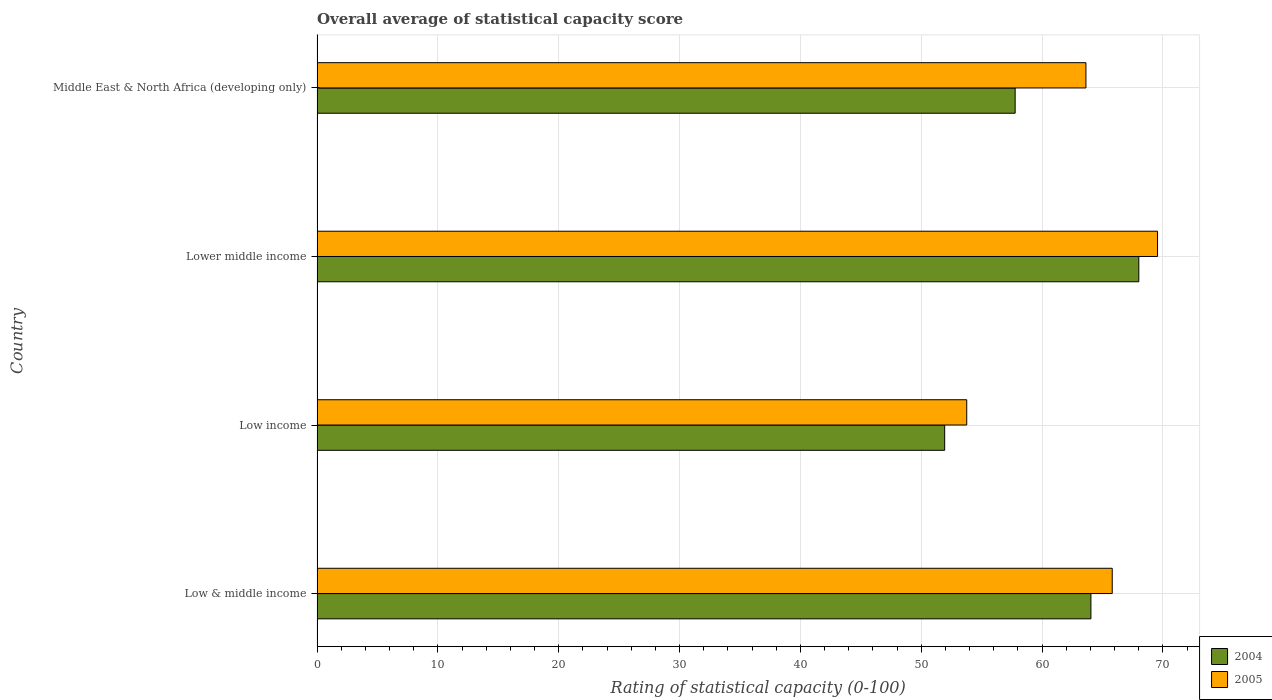How many different coloured bars are there?
Give a very brief answer. 2. Are the number of bars on each tick of the Y-axis equal?
Your answer should be very brief. Yes. How many bars are there on the 4th tick from the bottom?
Your answer should be compact. 2. What is the label of the 1st group of bars from the top?
Make the answer very short. Middle East & North Africa (developing only). In how many cases, is the number of bars for a given country not equal to the number of legend labels?
Your answer should be very brief. 0. What is the rating of statistical capacity in 2005 in Low & middle income?
Offer a terse response. 65.81. Across all countries, what is the maximum rating of statistical capacity in 2004?
Provide a short and direct response. 68.01. Across all countries, what is the minimum rating of statistical capacity in 2004?
Offer a terse response. 51.94. In which country was the rating of statistical capacity in 2005 maximum?
Give a very brief answer. Lower middle income. What is the total rating of statistical capacity in 2005 in the graph?
Your answer should be very brief. 252.78. What is the difference between the rating of statistical capacity in 2005 in Low income and that in Lower middle income?
Give a very brief answer. -15.79. What is the difference between the rating of statistical capacity in 2004 in Low income and the rating of statistical capacity in 2005 in Low & middle income?
Your answer should be very brief. -13.87. What is the average rating of statistical capacity in 2005 per country?
Give a very brief answer. 63.19. What is the difference between the rating of statistical capacity in 2005 and rating of statistical capacity in 2004 in Middle East & North Africa (developing only)?
Your answer should be compact. 5.86. What is the ratio of the rating of statistical capacity in 2004 in Lower middle income to that in Middle East & North Africa (developing only)?
Offer a terse response. 1.18. Is the difference between the rating of statistical capacity in 2005 in Low & middle income and Low income greater than the difference between the rating of statistical capacity in 2004 in Low & middle income and Low income?
Offer a terse response. No. What is the difference between the highest and the second highest rating of statistical capacity in 2004?
Give a very brief answer. 3.96. What is the difference between the highest and the lowest rating of statistical capacity in 2005?
Make the answer very short. 15.79. In how many countries, is the rating of statistical capacity in 2005 greater than the average rating of statistical capacity in 2005 taken over all countries?
Make the answer very short. 3. What does the 2nd bar from the top in Middle East & North Africa (developing only) represents?
Keep it short and to the point. 2004. Are the values on the major ticks of X-axis written in scientific E-notation?
Keep it short and to the point. No. Does the graph contain any zero values?
Your response must be concise. No. What is the title of the graph?
Offer a very short reply. Overall average of statistical capacity score. What is the label or title of the X-axis?
Your answer should be compact. Rating of statistical capacity (0-100). What is the Rating of statistical capacity (0-100) of 2004 in Low & middle income?
Keep it short and to the point. 64.05. What is the Rating of statistical capacity (0-100) in 2005 in Low & middle income?
Your answer should be compact. 65.81. What is the Rating of statistical capacity (0-100) in 2004 in Low income?
Keep it short and to the point. 51.94. What is the Rating of statistical capacity (0-100) of 2005 in Low income?
Your answer should be compact. 53.77. What is the Rating of statistical capacity (0-100) in 2004 in Lower middle income?
Your answer should be very brief. 68.01. What is the Rating of statistical capacity (0-100) in 2005 in Lower middle income?
Your answer should be compact. 69.56. What is the Rating of statistical capacity (0-100) in 2004 in Middle East & North Africa (developing only)?
Provide a short and direct response. 57.78. What is the Rating of statistical capacity (0-100) of 2005 in Middle East & North Africa (developing only)?
Offer a very short reply. 63.64. Across all countries, what is the maximum Rating of statistical capacity (0-100) in 2004?
Make the answer very short. 68.01. Across all countries, what is the maximum Rating of statistical capacity (0-100) in 2005?
Your answer should be very brief. 69.56. Across all countries, what is the minimum Rating of statistical capacity (0-100) in 2004?
Offer a terse response. 51.94. Across all countries, what is the minimum Rating of statistical capacity (0-100) in 2005?
Offer a terse response. 53.77. What is the total Rating of statistical capacity (0-100) of 2004 in the graph?
Offer a terse response. 241.78. What is the total Rating of statistical capacity (0-100) of 2005 in the graph?
Your answer should be compact. 252.78. What is the difference between the Rating of statistical capacity (0-100) in 2004 in Low & middle income and that in Low income?
Keep it short and to the point. 12.1. What is the difference between the Rating of statistical capacity (0-100) of 2005 in Low & middle income and that in Low income?
Provide a succinct answer. 12.04. What is the difference between the Rating of statistical capacity (0-100) in 2004 in Low & middle income and that in Lower middle income?
Give a very brief answer. -3.96. What is the difference between the Rating of statistical capacity (0-100) in 2005 in Low & middle income and that in Lower middle income?
Your response must be concise. -3.75. What is the difference between the Rating of statistical capacity (0-100) in 2004 in Low & middle income and that in Middle East & North Africa (developing only)?
Ensure brevity in your answer.  6.27. What is the difference between the Rating of statistical capacity (0-100) of 2005 in Low & middle income and that in Middle East & North Africa (developing only)?
Your response must be concise. 2.18. What is the difference between the Rating of statistical capacity (0-100) of 2004 in Low income and that in Lower middle income?
Keep it short and to the point. -16.07. What is the difference between the Rating of statistical capacity (0-100) of 2005 in Low income and that in Lower middle income?
Your answer should be very brief. -15.79. What is the difference between the Rating of statistical capacity (0-100) in 2004 in Low income and that in Middle East & North Africa (developing only)?
Your response must be concise. -5.83. What is the difference between the Rating of statistical capacity (0-100) in 2005 in Low income and that in Middle East & North Africa (developing only)?
Keep it short and to the point. -9.87. What is the difference between the Rating of statistical capacity (0-100) of 2004 in Lower middle income and that in Middle East & North Africa (developing only)?
Give a very brief answer. 10.23. What is the difference between the Rating of statistical capacity (0-100) of 2005 in Lower middle income and that in Middle East & North Africa (developing only)?
Make the answer very short. 5.92. What is the difference between the Rating of statistical capacity (0-100) of 2004 in Low & middle income and the Rating of statistical capacity (0-100) of 2005 in Low income?
Your response must be concise. 10.28. What is the difference between the Rating of statistical capacity (0-100) in 2004 in Low & middle income and the Rating of statistical capacity (0-100) in 2005 in Lower middle income?
Your answer should be very brief. -5.51. What is the difference between the Rating of statistical capacity (0-100) of 2004 in Low & middle income and the Rating of statistical capacity (0-100) of 2005 in Middle East & North Africa (developing only)?
Your answer should be very brief. 0.41. What is the difference between the Rating of statistical capacity (0-100) in 2004 in Low income and the Rating of statistical capacity (0-100) in 2005 in Lower middle income?
Your answer should be compact. -17.62. What is the difference between the Rating of statistical capacity (0-100) of 2004 in Low income and the Rating of statistical capacity (0-100) of 2005 in Middle East & North Africa (developing only)?
Give a very brief answer. -11.69. What is the difference between the Rating of statistical capacity (0-100) of 2004 in Lower middle income and the Rating of statistical capacity (0-100) of 2005 in Middle East & North Africa (developing only)?
Your answer should be very brief. 4.38. What is the average Rating of statistical capacity (0-100) in 2004 per country?
Keep it short and to the point. 60.45. What is the average Rating of statistical capacity (0-100) in 2005 per country?
Ensure brevity in your answer.  63.19. What is the difference between the Rating of statistical capacity (0-100) in 2004 and Rating of statistical capacity (0-100) in 2005 in Low & middle income?
Ensure brevity in your answer.  -1.76. What is the difference between the Rating of statistical capacity (0-100) of 2004 and Rating of statistical capacity (0-100) of 2005 in Low income?
Give a very brief answer. -1.83. What is the difference between the Rating of statistical capacity (0-100) in 2004 and Rating of statistical capacity (0-100) in 2005 in Lower middle income?
Your answer should be compact. -1.55. What is the difference between the Rating of statistical capacity (0-100) in 2004 and Rating of statistical capacity (0-100) in 2005 in Middle East & North Africa (developing only)?
Offer a terse response. -5.86. What is the ratio of the Rating of statistical capacity (0-100) of 2004 in Low & middle income to that in Low income?
Ensure brevity in your answer.  1.23. What is the ratio of the Rating of statistical capacity (0-100) in 2005 in Low & middle income to that in Low income?
Make the answer very short. 1.22. What is the ratio of the Rating of statistical capacity (0-100) of 2004 in Low & middle income to that in Lower middle income?
Offer a very short reply. 0.94. What is the ratio of the Rating of statistical capacity (0-100) of 2005 in Low & middle income to that in Lower middle income?
Your response must be concise. 0.95. What is the ratio of the Rating of statistical capacity (0-100) of 2004 in Low & middle income to that in Middle East & North Africa (developing only)?
Your answer should be compact. 1.11. What is the ratio of the Rating of statistical capacity (0-100) of 2005 in Low & middle income to that in Middle East & North Africa (developing only)?
Provide a short and direct response. 1.03. What is the ratio of the Rating of statistical capacity (0-100) of 2004 in Low income to that in Lower middle income?
Keep it short and to the point. 0.76. What is the ratio of the Rating of statistical capacity (0-100) in 2005 in Low income to that in Lower middle income?
Ensure brevity in your answer.  0.77. What is the ratio of the Rating of statistical capacity (0-100) in 2004 in Low income to that in Middle East & North Africa (developing only)?
Offer a terse response. 0.9. What is the ratio of the Rating of statistical capacity (0-100) in 2005 in Low income to that in Middle East & North Africa (developing only)?
Ensure brevity in your answer.  0.84. What is the ratio of the Rating of statistical capacity (0-100) of 2004 in Lower middle income to that in Middle East & North Africa (developing only)?
Offer a very short reply. 1.18. What is the ratio of the Rating of statistical capacity (0-100) of 2005 in Lower middle income to that in Middle East & North Africa (developing only)?
Your answer should be very brief. 1.09. What is the difference between the highest and the second highest Rating of statistical capacity (0-100) of 2004?
Offer a very short reply. 3.96. What is the difference between the highest and the second highest Rating of statistical capacity (0-100) in 2005?
Offer a terse response. 3.75. What is the difference between the highest and the lowest Rating of statistical capacity (0-100) of 2004?
Keep it short and to the point. 16.07. What is the difference between the highest and the lowest Rating of statistical capacity (0-100) of 2005?
Keep it short and to the point. 15.79. 